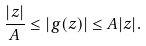<formula> <loc_0><loc_0><loc_500><loc_500>\frac { | z | } { A } \leq | g ( z ) | \leq A | z | .</formula> 